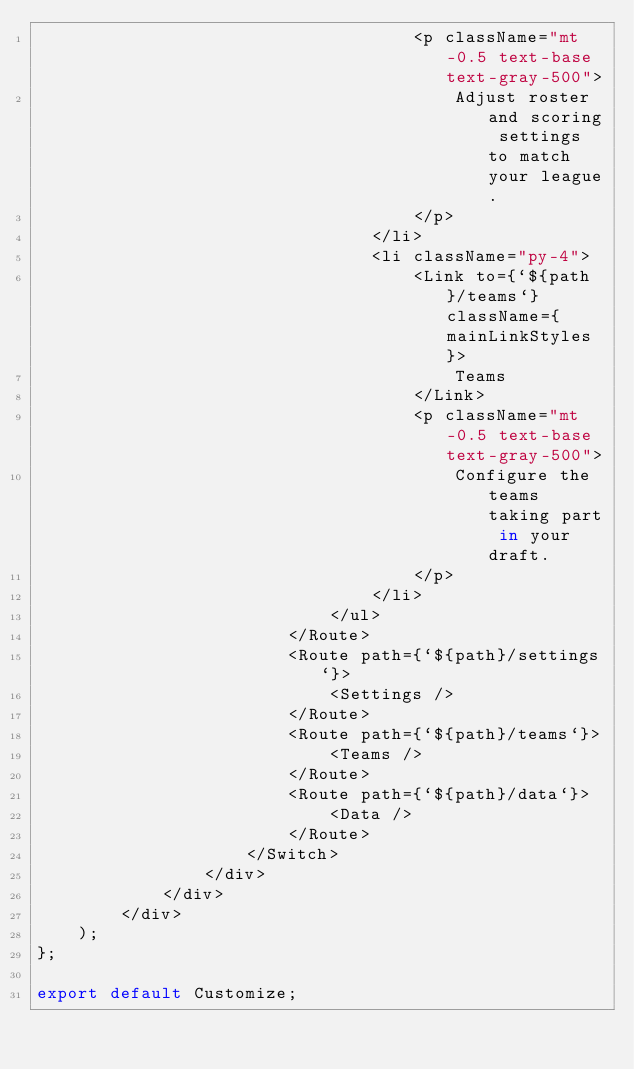Convert code to text. <code><loc_0><loc_0><loc_500><loc_500><_TypeScript_>                                    <p className="mt-0.5 text-base text-gray-500">
                                        Adjust roster and scoring settings to match your league.
                                    </p>
                                </li>
                                <li className="py-4">
                                    <Link to={`${path}/teams`} className={mainLinkStyles}>
                                        Teams
                                    </Link>
                                    <p className="mt-0.5 text-base text-gray-500">
                                        Configure the teams taking part in your draft.
                                    </p>
                                </li>
                            </ul>
                        </Route>
                        <Route path={`${path}/settings`}>
                            <Settings />
                        </Route>
                        <Route path={`${path}/teams`}>
                            <Teams />
                        </Route>
                        <Route path={`${path}/data`}>
                            <Data />
                        </Route>
                    </Switch>
                </div>
            </div>
        </div>
    );
};

export default Customize;
</code> 